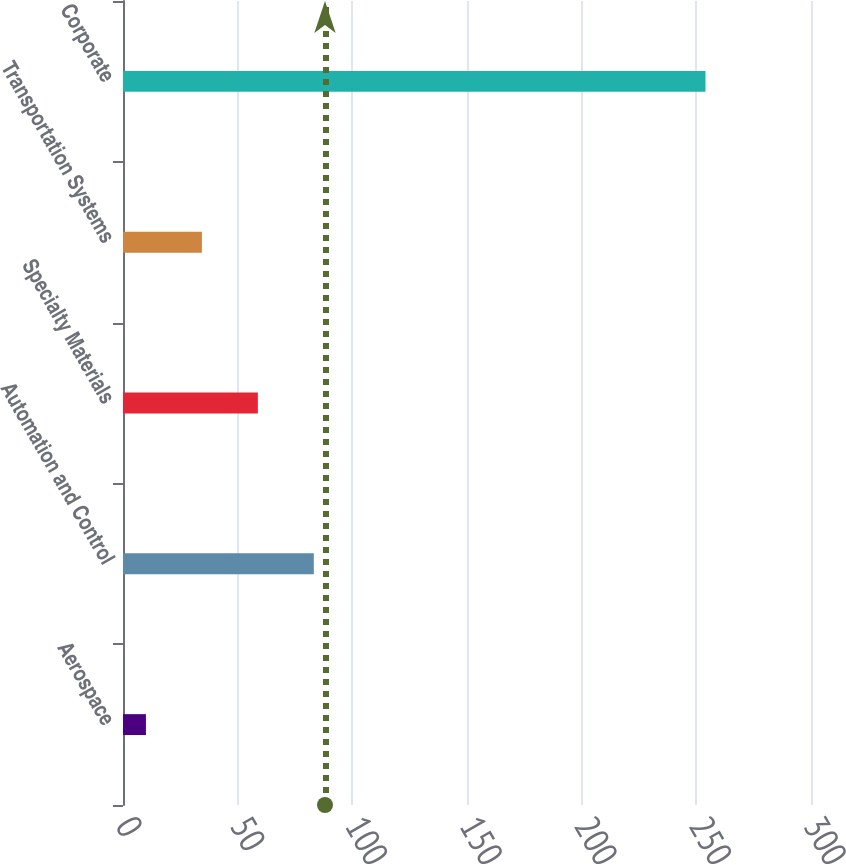Convert chart. <chart><loc_0><loc_0><loc_500><loc_500><bar_chart><fcel>Aerospace<fcel>Automation and Control<fcel>Specialty Materials<fcel>Transportation Systems<fcel>Corporate<nl><fcel>10<fcel>83.2<fcel>58.8<fcel>34.4<fcel>254<nl></chart> 